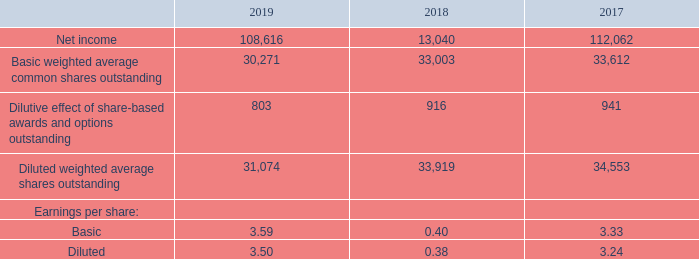7. Earnings Per Share
The following is a reconciliation of the amounts utilized in the computation of basic and diluted earnings per share for fiscal2 019, 2018 and 2017 (in thousands, except per share amounts):
In each of the fiscal years 2019, 2018 and 2017, share-based awards for approximately 0.1 million shares were not included in the computation of diluted earnings per share as they were antidilutive.
Which years does the table provide information for the amounts utilized in the computation of basic and diluted earnings per share? 2019, 2018, 2017. What was the amount of net income in 2017?
Answer scale should be: thousand. 112,062. What was the amount of basic earnings per share in 2019? 3.59. How many years did net income exceed $100,000 thousand? 2019##2017
Answer: 2. What was the change in the Basic weighted average common shares outstanding between 2018 and 2019?
Answer scale should be: thousand. 30,271-33,612
Answer: -3341. What was the percentage change in the diluted earnings per share between 2017 and 2019?
Answer scale should be: percent. (3.50-3.24)/3.24
Answer: 8.02. 